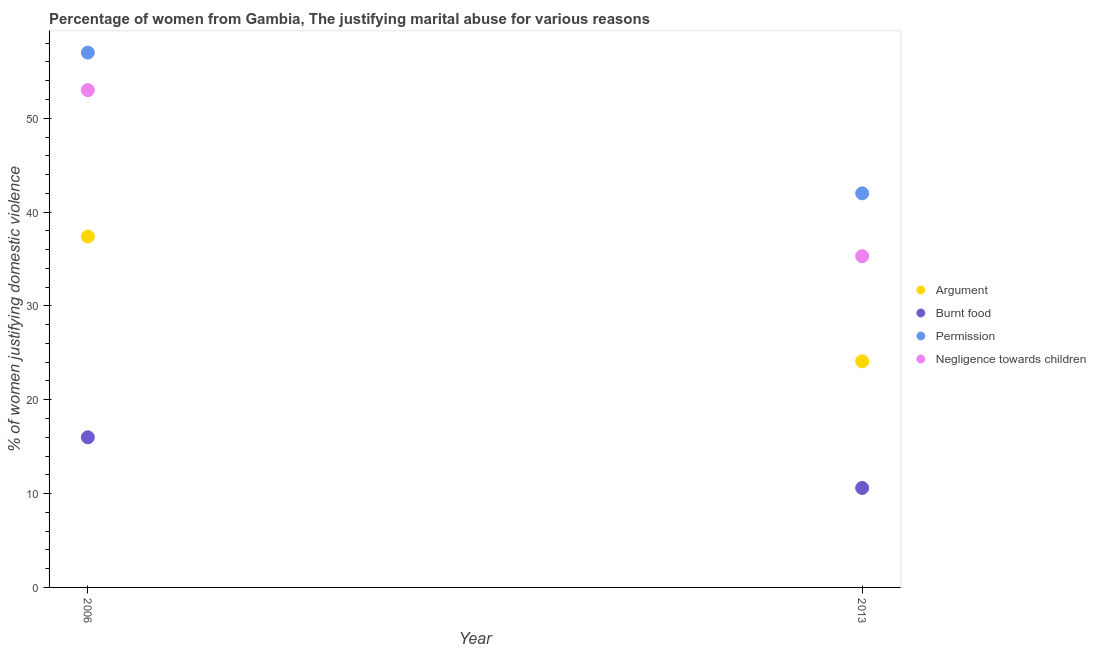What is the percentage of women justifying abuse for showing negligence towards children in 2013?
Your answer should be compact. 35.3. Across all years, what is the minimum percentage of women justifying abuse in the case of an argument?
Give a very brief answer. 24.1. In which year was the percentage of women justifying abuse for going without permission maximum?
Offer a very short reply. 2006. What is the total percentage of women justifying abuse for going without permission in the graph?
Offer a terse response. 99. What is the difference between the percentage of women justifying abuse for going without permission in 2006 and that in 2013?
Your answer should be very brief. 15. What is the difference between the percentage of women justifying abuse for burning food in 2006 and the percentage of women justifying abuse for showing negligence towards children in 2013?
Offer a very short reply. -19.3. What is the average percentage of women justifying abuse for burning food per year?
Give a very brief answer. 13.3. In the year 2006, what is the difference between the percentage of women justifying abuse in the case of an argument and percentage of women justifying abuse for showing negligence towards children?
Provide a short and direct response. -15.6. What is the ratio of the percentage of women justifying abuse for showing negligence towards children in 2006 to that in 2013?
Your answer should be very brief. 1.5. Is it the case that in every year, the sum of the percentage of women justifying abuse for going without permission and percentage of women justifying abuse in the case of an argument is greater than the sum of percentage of women justifying abuse for showing negligence towards children and percentage of women justifying abuse for burning food?
Give a very brief answer. No. Is the percentage of women justifying abuse in the case of an argument strictly greater than the percentage of women justifying abuse for showing negligence towards children over the years?
Provide a succinct answer. No. How many dotlines are there?
Provide a short and direct response. 4. What is the difference between two consecutive major ticks on the Y-axis?
Provide a short and direct response. 10. Does the graph contain any zero values?
Your answer should be very brief. No. How are the legend labels stacked?
Offer a terse response. Vertical. What is the title of the graph?
Your answer should be very brief. Percentage of women from Gambia, The justifying marital abuse for various reasons. What is the label or title of the Y-axis?
Make the answer very short. % of women justifying domestic violence. What is the % of women justifying domestic violence of Argument in 2006?
Provide a short and direct response. 37.4. What is the % of women justifying domestic violence in Burnt food in 2006?
Give a very brief answer. 16. What is the % of women justifying domestic violence in Permission in 2006?
Your answer should be compact. 57. What is the % of women justifying domestic violence in Negligence towards children in 2006?
Give a very brief answer. 53. What is the % of women justifying domestic violence of Argument in 2013?
Your response must be concise. 24.1. What is the % of women justifying domestic violence of Burnt food in 2013?
Your response must be concise. 10.6. What is the % of women justifying domestic violence in Negligence towards children in 2013?
Provide a succinct answer. 35.3. Across all years, what is the maximum % of women justifying domestic violence of Argument?
Offer a very short reply. 37.4. Across all years, what is the minimum % of women justifying domestic violence of Argument?
Your response must be concise. 24.1. Across all years, what is the minimum % of women justifying domestic violence in Burnt food?
Your answer should be compact. 10.6. Across all years, what is the minimum % of women justifying domestic violence of Permission?
Provide a short and direct response. 42. Across all years, what is the minimum % of women justifying domestic violence of Negligence towards children?
Keep it short and to the point. 35.3. What is the total % of women justifying domestic violence of Argument in the graph?
Your answer should be compact. 61.5. What is the total % of women justifying domestic violence of Burnt food in the graph?
Offer a very short reply. 26.6. What is the total % of women justifying domestic violence in Permission in the graph?
Your response must be concise. 99. What is the total % of women justifying domestic violence of Negligence towards children in the graph?
Keep it short and to the point. 88.3. What is the difference between the % of women justifying domestic violence in Argument in 2006 and that in 2013?
Offer a very short reply. 13.3. What is the difference between the % of women justifying domestic violence of Burnt food in 2006 and that in 2013?
Give a very brief answer. 5.4. What is the difference between the % of women justifying domestic violence of Permission in 2006 and that in 2013?
Keep it short and to the point. 15. What is the difference between the % of women justifying domestic violence of Negligence towards children in 2006 and that in 2013?
Your answer should be compact. 17.7. What is the difference between the % of women justifying domestic violence in Argument in 2006 and the % of women justifying domestic violence in Burnt food in 2013?
Give a very brief answer. 26.8. What is the difference between the % of women justifying domestic violence in Argument in 2006 and the % of women justifying domestic violence in Permission in 2013?
Offer a very short reply. -4.6. What is the difference between the % of women justifying domestic violence of Argument in 2006 and the % of women justifying domestic violence of Negligence towards children in 2013?
Keep it short and to the point. 2.1. What is the difference between the % of women justifying domestic violence in Burnt food in 2006 and the % of women justifying domestic violence in Negligence towards children in 2013?
Provide a succinct answer. -19.3. What is the difference between the % of women justifying domestic violence of Permission in 2006 and the % of women justifying domestic violence of Negligence towards children in 2013?
Offer a terse response. 21.7. What is the average % of women justifying domestic violence of Argument per year?
Offer a terse response. 30.75. What is the average % of women justifying domestic violence of Burnt food per year?
Offer a terse response. 13.3. What is the average % of women justifying domestic violence in Permission per year?
Make the answer very short. 49.5. What is the average % of women justifying domestic violence of Negligence towards children per year?
Your answer should be very brief. 44.15. In the year 2006, what is the difference between the % of women justifying domestic violence of Argument and % of women justifying domestic violence of Burnt food?
Offer a very short reply. 21.4. In the year 2006, what is the difference between the % of women justifying domestic violence of Argument and % of women justifying domestic violence of Permission?
Give a very brief answer. -19.6. In the year 2006, what is the difference between the % of women justifying domestic violence in Argument and % of women justifying domestic violence in Negligence towards children?
Your response must be concise. -15.6. In the year 2006, what is the difference between the % of women justifying domestic violence of Burnt food and % of women justifying domestic violence of Permission?
Provide a succinct answer. -41. In the year 2006, what is the difference between the % of women justifying domestic violence in Burnt food and % of women justifying domestic violence in Negligence towards children?
Offer a terse response. -37. In the year 2013, what is the difference between the % of women justifying domestic violence in Argument and % of women justifying domestic violence in Permission?
Offer a very short reply. -17.9. In the year 2013, what is the difference between the % of women justifying domestic violence in Argument and % of women justifying domestic violence in Negligence towards children?
Provide a short and direct response. -11.2. In the year 2013, what is the difference between the % of women justifying domestic violence in Burnt food and % of women justifying domestic violence in Permission?
Make the answer very short. -31.4. In the year 2013, what is the difference between the % of women justifying domestic violence in Burnt food and % of women justifying domestic violence in Negligence towards children?
Keep it short and to the point. -24.7. What is the ratio of the % of women justifying domestic violence of Argument in 2006 to that in 2013?
Give a very brief answer. 1.55. What is the ratio of the % of women justifying domestic violence in Burnt food in 2006 to that in 2013?
Make the answer very short. 1.51. What is the ratio of the % of women justifying domestic violence in Permission in 2006 to that in 2013?
Make the answer very short. 1.36. What is the ratio of the % of women justifying domestic violence in Negligence towards children in 2006 to that in 2013?
Keep it short and to the point. 1.5. What is the difference between the highest and the second highest % of women justifying domestic violence in Argument?
Provide a short and direct response. 13.3. What is the difference between the highest and the second highest % of women justifying domestic violence of Burnt food?
Keep it short and to the point. 5.4. What is the difference between the highest and the second highest % of women justifying domestic violence in Negligence towards children?
Make the answer very short. 17.7. What is the difference between the highest and the lowest % of women justifying domestic violence in Burnt food?
Ensure brevity in your answer.  5.4. 